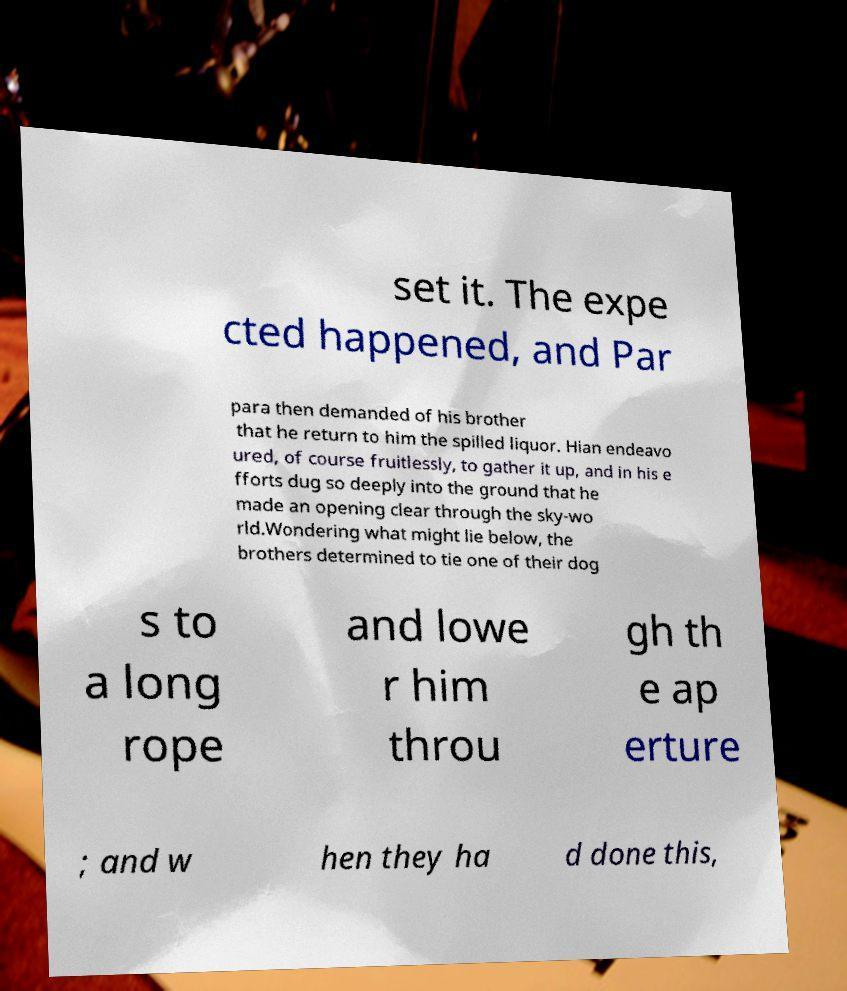Please identify and transcribe the text found in this image. set it. The expe cted happened, and Par para then demanded of his brother that he return to him the spilled liquor. Hian endeavo ured, of course fruitlessly, to gather it up, and in his e fforts dug so deeply into the ground that he made an opening clear through the sky-wo rld.Wondering what might lie below, the brothers determined to tie one of their dog s to a long rope and lowe r him throu gh th e ap erture ; and w hen they ha d done this, 